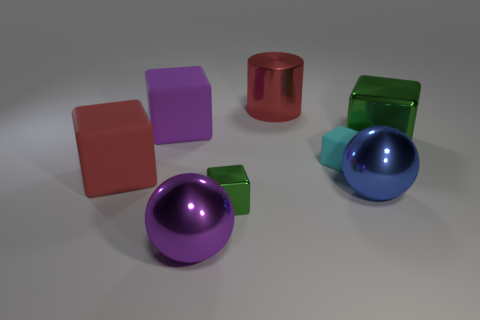How many objects are balls or green metal cubes that are right of the metal cylinder? There are three objects that fit the description: one purple ball, one blue ball, and one small green metal cube, all located to the right of the red metal cylinder. 